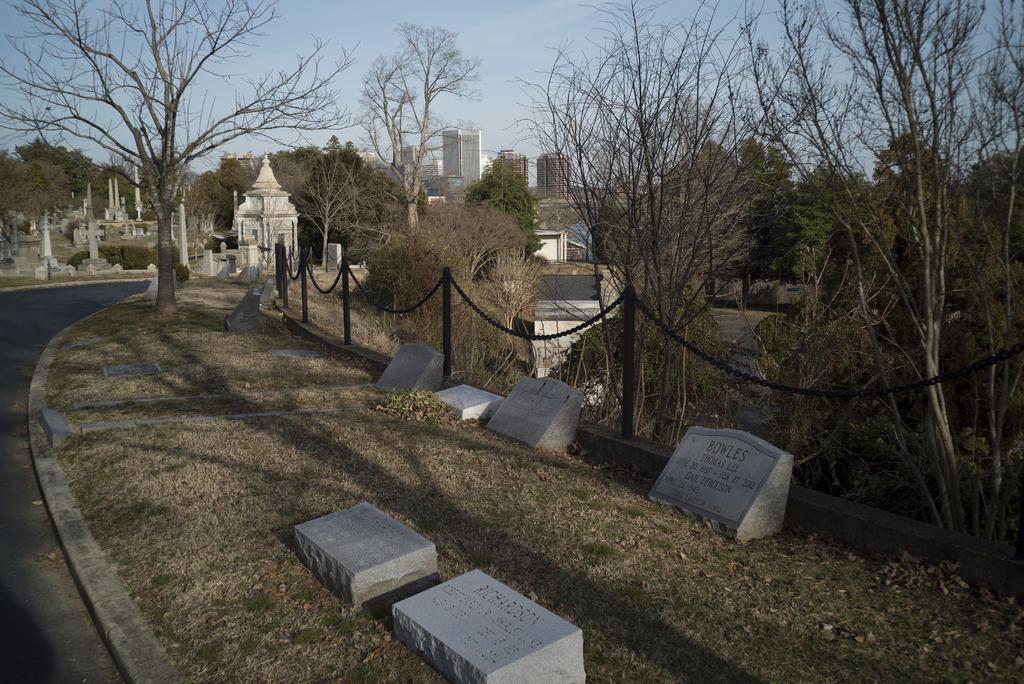How would you summarize this image in a sentence or two? In this image we can see some buildings in the background, some gravestones on the ground, some poles with chains, some gravestones with text on the ground, one road, some trees, some dried leaves and grass on the ground. At the top there is the sky. 